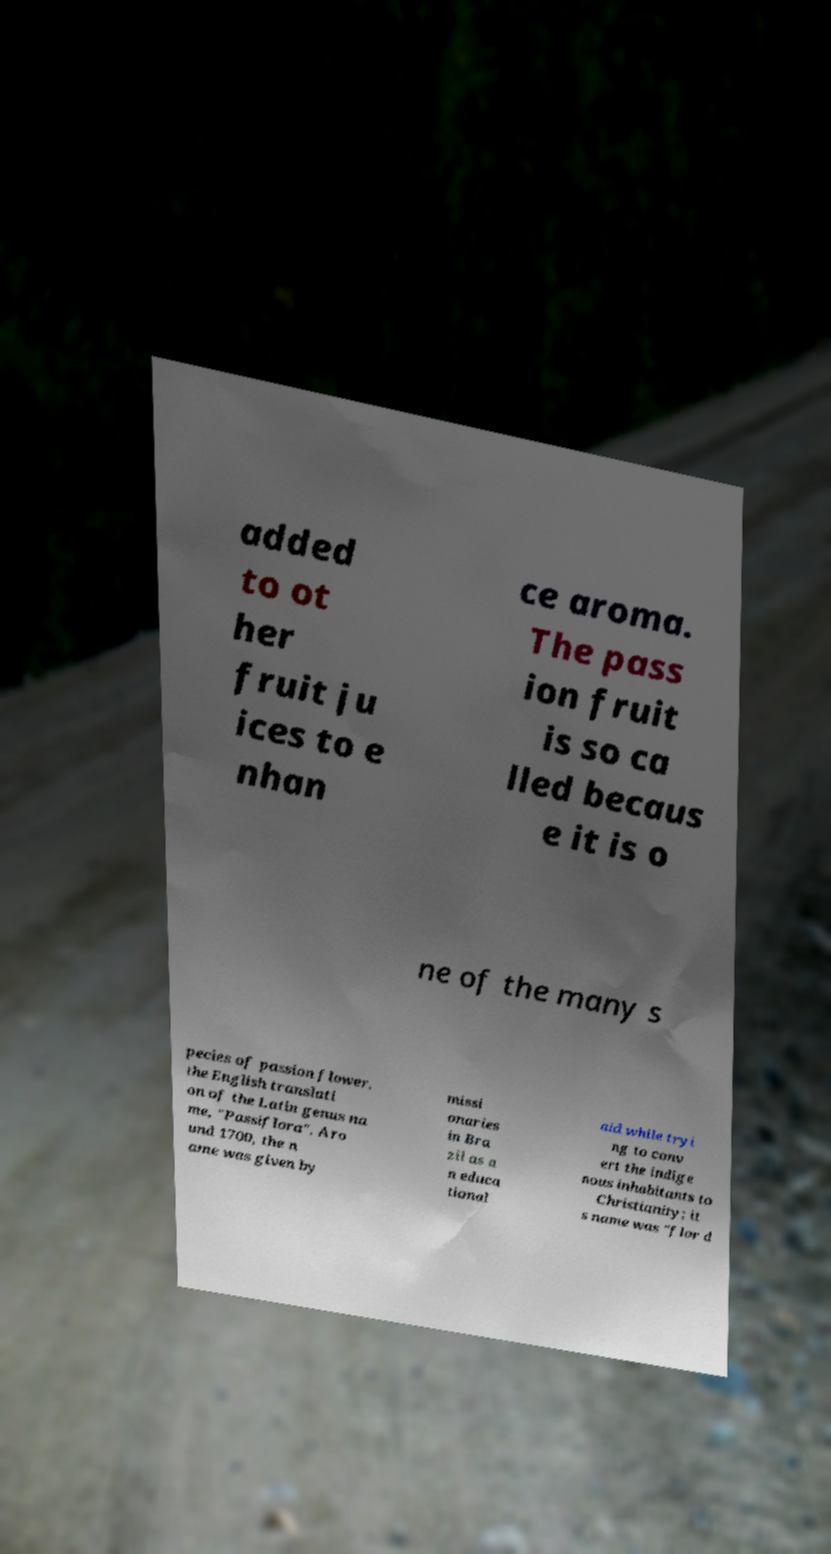Please identify and transcribe the text found in this image. added to ot her fruit ju ices to e nhan ce aroma. The pass ion fruit is so ca lled becaus e it is o ne of the many s pecies of passion flower, the English translati on of the Latin genus na me, "Passiflora". Aro und 1700, the n ame was given by missi onaries in Bra zil as a n educa tional aid while tryi ng to conv ert the indige nous inhabitants to Christianity; it s name was "flor d 